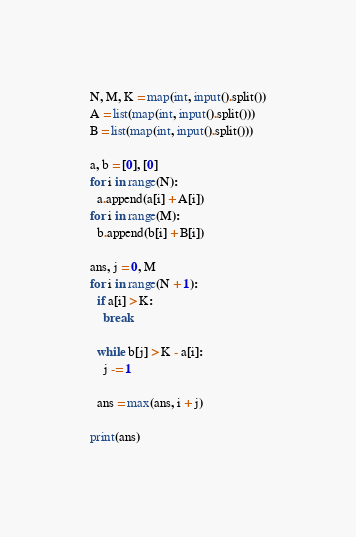<code> <loc_0><loc_0><loc_500><loc_500><_Python_>N, M, K = map(int, input().split())
A = list(map(int, input().split()))
B = list(map(int, input().split()))

a, b = [0], [0]
for i in range(N):
  a.append(a[i] + A[i])
for i in range(M):
  b.append(b[i] + B[i])

ans, j = 0, M
for i in range(N + 1):
  if a[i] > K:
    break
    
  while b[j] > K - a[i]:
    j -= 1
    
  ans = max(ans, i + j)

print(ans)</code> 